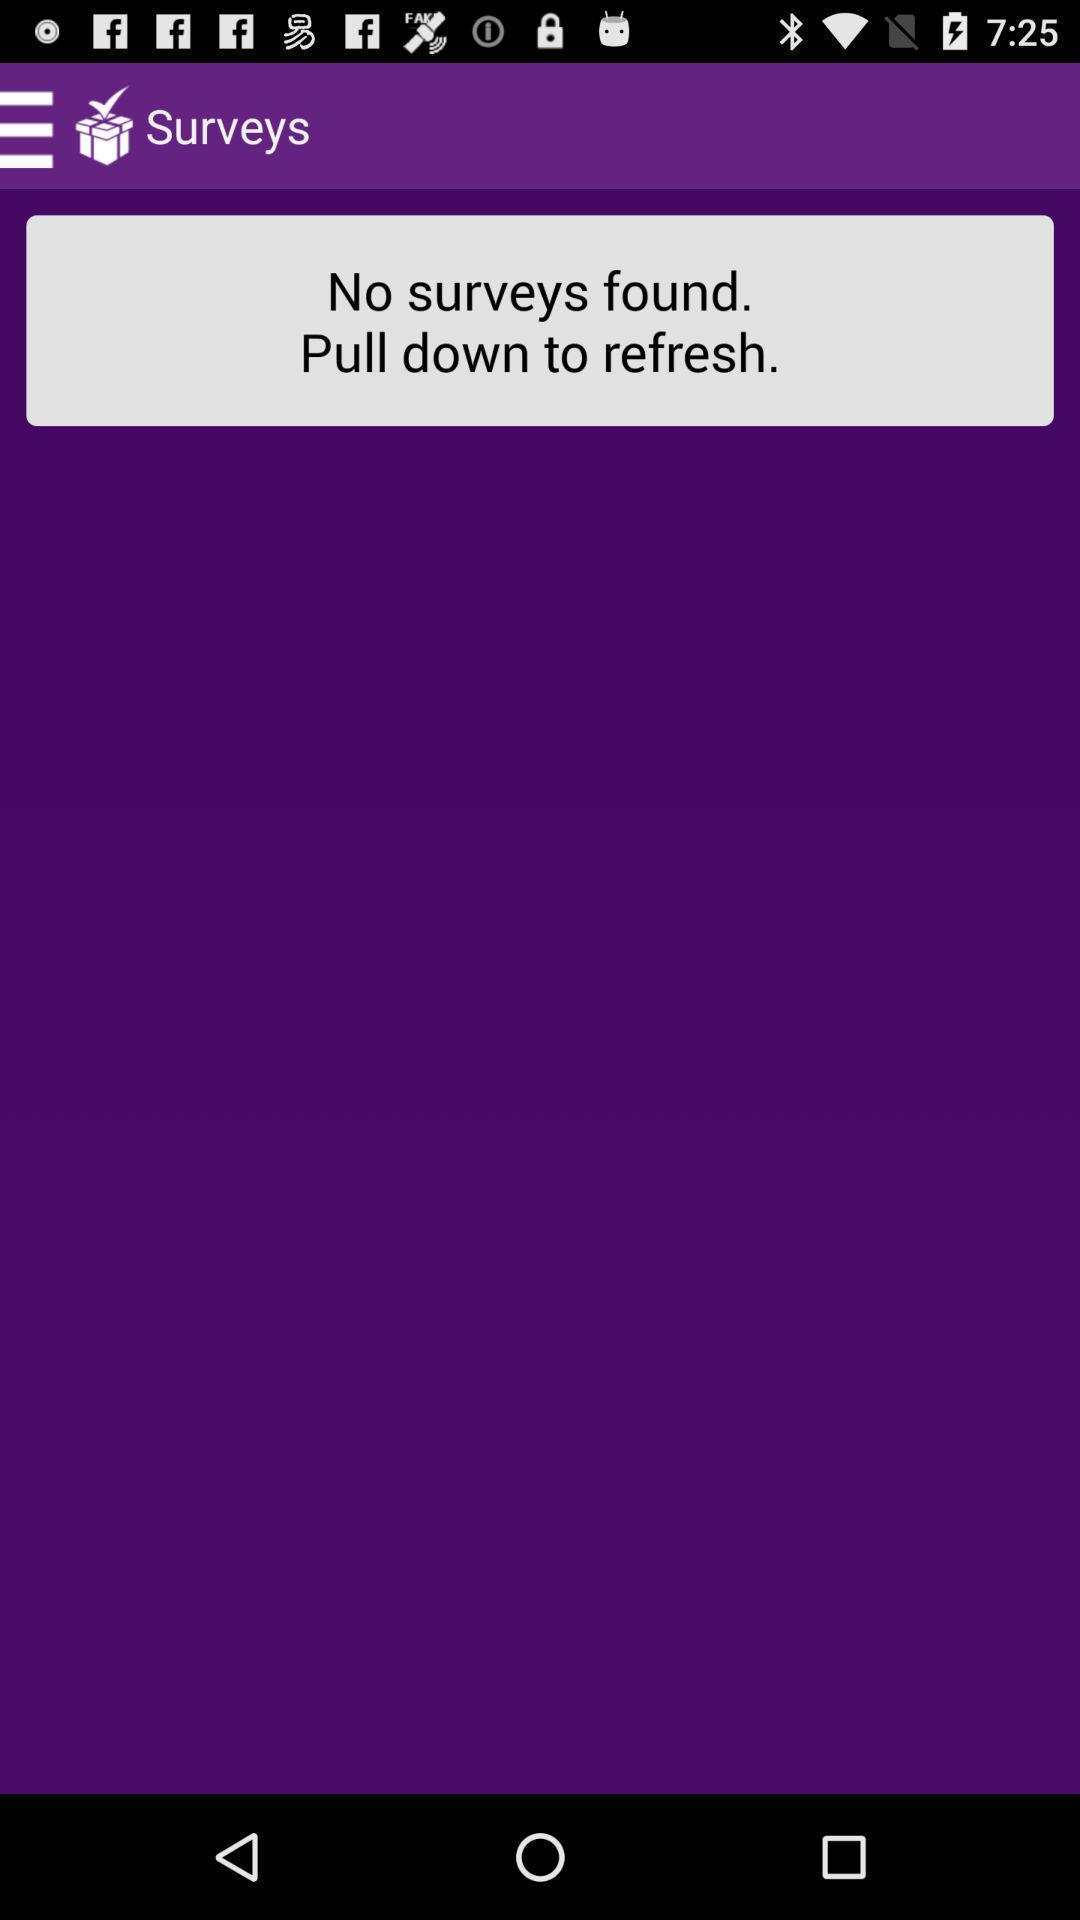Tell me about the visual elements in this screen capture. Survey page. 